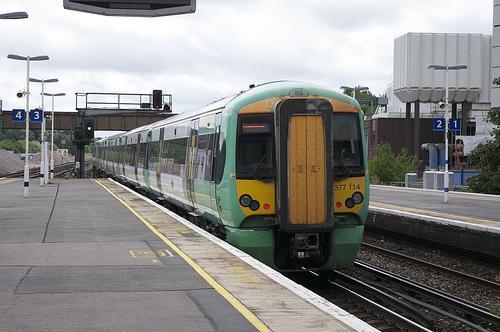How many sets of tracks are in the picture?
Give a very brief answer. 2. How many numbered platforms are shown?
Give a very brief answer. 4. 